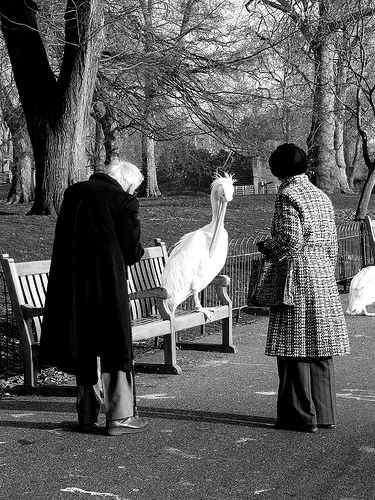Can you describe the interaction between the people and the bird in the image? Two people are standing closely by a bench, observing or interacting with a large white bird standing on the bench. What might these people be doing with the bird? They might be feeding or simply observing the bird. It's also possible they are taking a photograph. Can you describe the environment around them in detail? The scene appears to take place in a park with tall trees and open space. The ground is paved, and there are several benches around. There is an iron gate in the background, possibly enclosing different sections. The weather seems cool based on the clothing of the individuals. Imagine the bird suddenly starts talking to the people. What might it say? "Hello there! It's a lovely day, isn't it? Thank you for stopping by to admire me. Do you have any tasty treats to share?" How might the people react to this talking bird? The people would likely be astonished and excited, possibly laughing in disbelief and trying to talk back to the bird. They might even call others to witness the unusual event. 